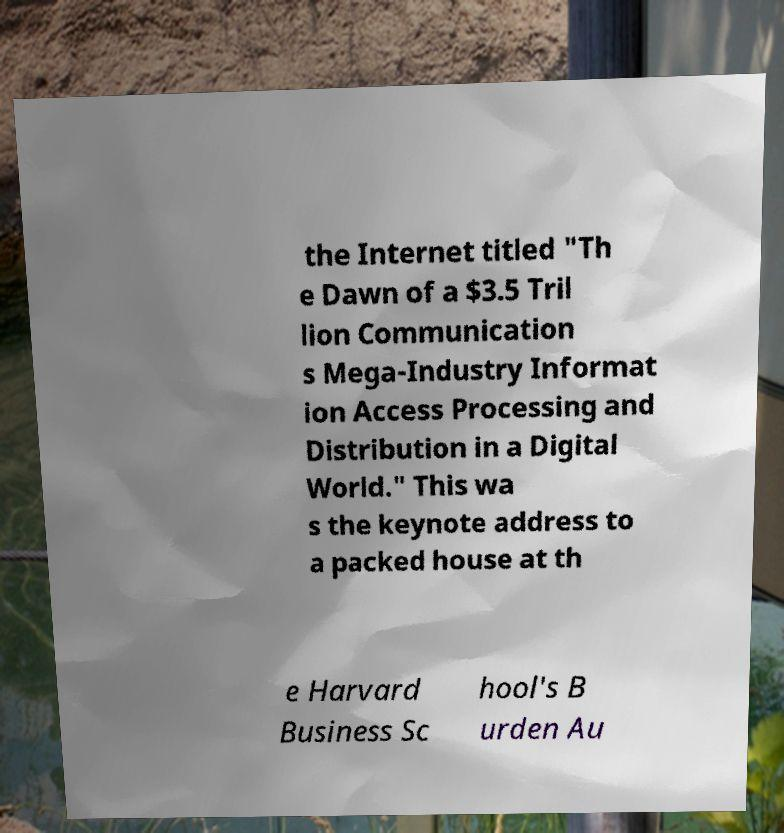Could you extract and type out the text from this image? the Internet titled "Th e Dawn of a $3.5 Tril lion Communication s Mega-Industry Informat ion Access Processing and Distribution in a Digital World." This wa s the keynote address to a packed house at th e Harvard Business Sc hool's B urden Au 